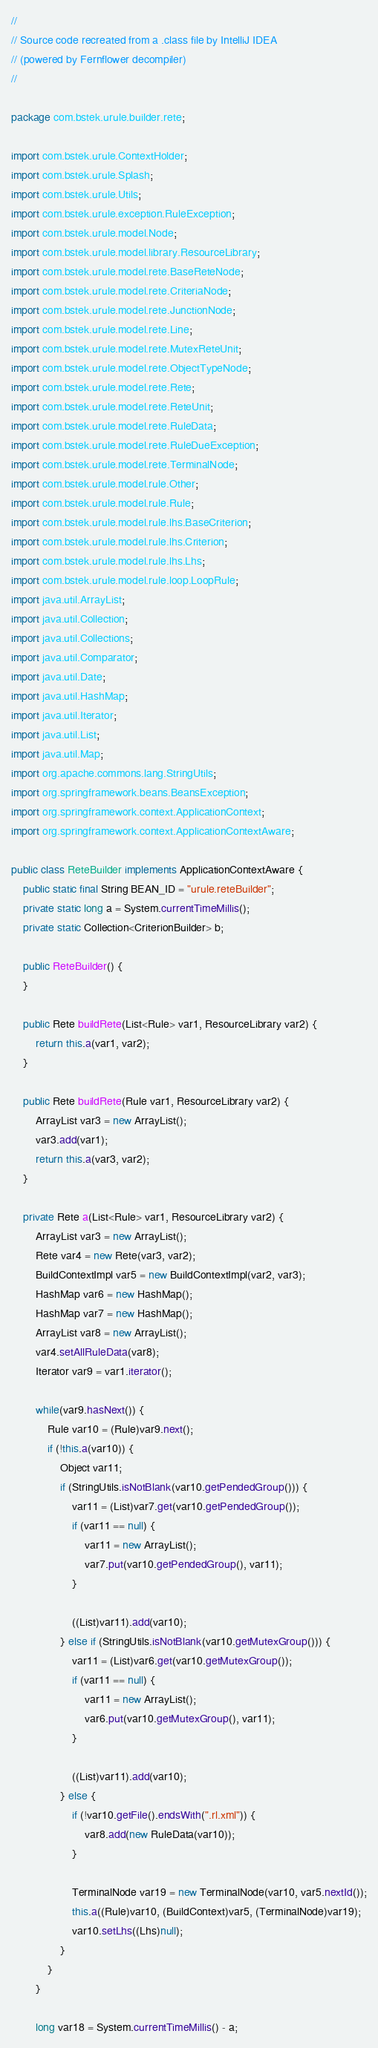Convert code to text. <code><loc_0><loc_0><loc_500><loc_500><_Java_>//
// Source code recreated from a .class file by IntelliJ IDEA
// (powered by Fernflower decompiler)
//

package com.bstek.urule.builder.rete;

import com.bstek.urule.ContextHolder;
import com.bstek.urule.Splash;
import com.bstek.urule.Utils;
import com.bstek.urule.exception.RuleException;
import com.bstek.urule.model.Node;
import com.bstek.urule.model.library.ResourceLibrary;
import com.bstek.urule.model.rete.BaseReteNode;
import com.bstek.urule.model.rete.CriteriaNode;
import com.bstek.urule.model.rete.JunctionNode;
import com.bstek.urule.model.rete.Line;
import com.bstek.urule.model.rete.MutexReteUnit;
import com.bstek.urule.model.rete.ObjectTypeNode;
import com.bstek.urule.model.rete.Rete;
import com.bstek.urule.model.rete.ReteUnit;
import com.bstek.urule.model.rete.RuleData;
import com.bstek.urule.model.rete.RuleDueException;
import com.bstek.urule.model.rete.TerminalNode;
import com.bstek.urule.model.rule.Other;
import com.bstek.urule.model.rule.Rule;
import com.bstek.urule.model.rule.lhs.BaseCriterion;
import com.bstek.urule.model.rule.lhs.Criterion;
import com.bstek.urule.model.rule.lhs.Lhs;
import com.bstek.urule.model.rule.loop.LoopRule;
import java.util.ArrayList;
import java.util.Collection;
import java.util.Collections;
import java.util.Comparator;
import java.util.Date;
import java.util.HashMap;
import java.util.Iterator;
import java.util.List;
import java.util.Map;
import org.apache.commons.lang.StringUtils;
import org.springframework.beans.BeansException;
import org.springframework.context.ApplicationContext;
import org.springframework.context.ApplicationContextAware;

public class ReteBuilder implements ApplicationContextAware {
    public static final String BEAN_ID = "urule.reteBuilder";
    private static long a = System.currentTimeMillis();
    private static Collection<CriterionBuilder> b;

    public ReteBuilder() {
    }

    public Rete buildRete(List<Rule> var1, ResourceLibrary var2) {
        return this.a(var1, var2);
    }

    public Rete buildRete(Rule var1, ResourceLibrary var2) {
        ArrayList var3 = new ArrayList();
        var3.add(var1);
        return this.a(var3, var2);
    }

    private Rete a(List<Rule> var1, ResourceLibrary var2) {
        ArrayList var3 = new ArrayList();
        Rete var4 = new Rete(var3, var2);
        BuildContextImpl var5 = new BuildContextImpl(var2, var3);
        HashMap var6 = new HashMap();
        HashMap var7 = new HashMap();
        ArrayList var8 = new ArrayList();
        var4.setAllRuleData(var8);
        Iterator var9 = var1.iterator();

        while(var9.hasNext()) {
            Rule var10 = (Rule)var9.next();
            if (!this.a(var10)) {
                Object var11;
                if (StringUtils.isNotBlank(var10.getPendedGroup())) {
                    var11 = (List)var7.get(var10.getPendedGroup());
                    if (var11 == null) {
                        var11 = new ArrayList();
                        var7.put(var10.getPendedGroup(), var11);
                    }

                    ((List)var11).add(var10);
                } else if (StringUtils.isNotBlank(var10.getMutexGroup())) {
                    var11 = (List)var6.get(var10.getMutexGroup());
                    if (var11 == null) {
                        var11 = new ArrayList();
                        var6.put(var10.getMutexGroup(), var11);
                    }

                    ((List)var11).add(var10);
                } else {
                    if (!var10.getFile().endsWith(".rl.xml")) {
                        var8.add(new RuleData(var10));
                    }

                    TerminalNode var19 = new TerminalNode(var10, var5.nextId());
                    this.a((Rule)var10, (BuildContext)var5, (TerminalNode)var19);
                    var10.setLhs((Lhs)null);
                }
            }
        }

        long var18 = System.currentTimeMillis() - a;</code> 